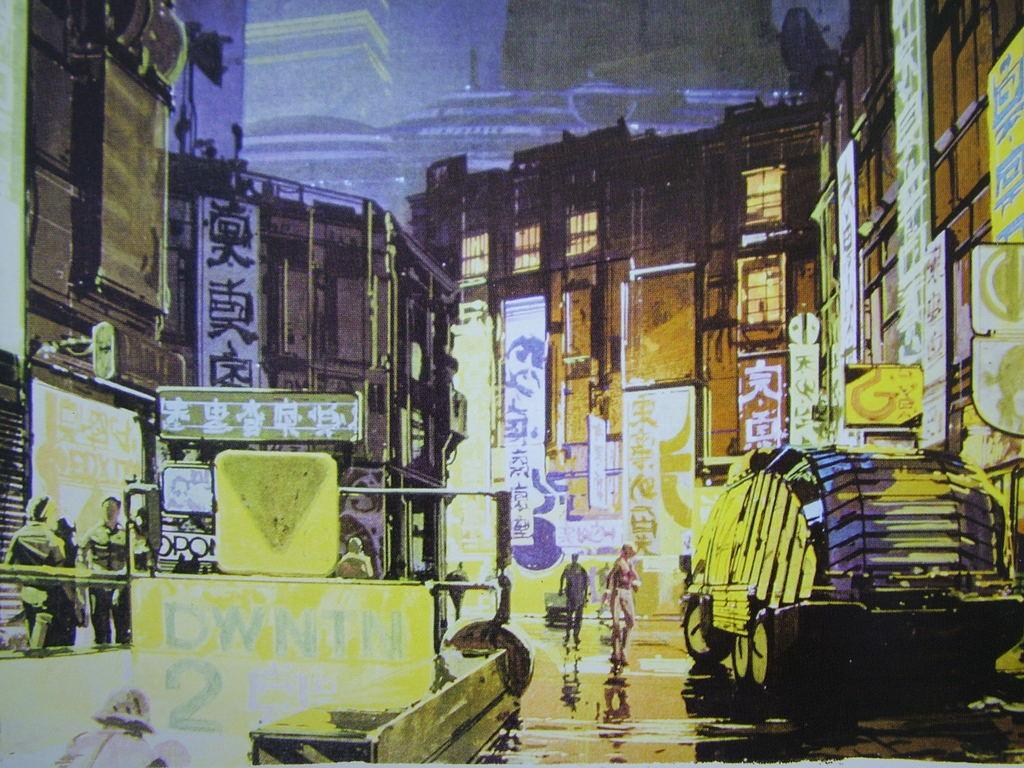How many people can be seen in the image? There are people in the image, but the exact number cannot be determined from the provided facts. What types of vehicles are present in the image? There are vehicles in the image, but the specific types cannot be determined from the provided facts. What kind of structures can be seen in the image? There are buildings in the image, but their specific characteristics cannot be determined from the provided facts. What do the posters in the image depict? The posters in the image have text, but their content cannot be determined from the provided facts. What is the purpose of the text in the image? The text in the image is present on posters and signboards, but its purpose cannot be determined from the provided facts. What is the condition of the road in the image? The road in the image is visible, but its condition cannot be determined from the provided facts. How many windows are present in the image? There are windows in the image, but the exact number cannot be determined from the provided facts. What do the signboards in the image indicate? The signboards in the image have text, but their content cannot be determined from the provided facts. What is the subway used for in the image? The subway in the image is a mode of transportation, but its specific purpose cannot be determined from the provided facts. What type of lights are present in the image? The lights in the image are present, but their specific type cannot be determined from the provided facts. Can you see clouds in the image? There is no mention of clouds in the provided facts, so they cannot be seen in the image. 